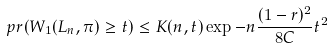Convert formula to latex. <formula><loc_0><loc_0><loc_500><loc_500>\ p r ( W _ { 1 } ( L _ { n } , \pi ) \geq t ) \leq K ( n , t ) \exp - n \frac { ( 1 - r ) ^ { 2 } } { 8 C } t ^ { 2 }</formula> 